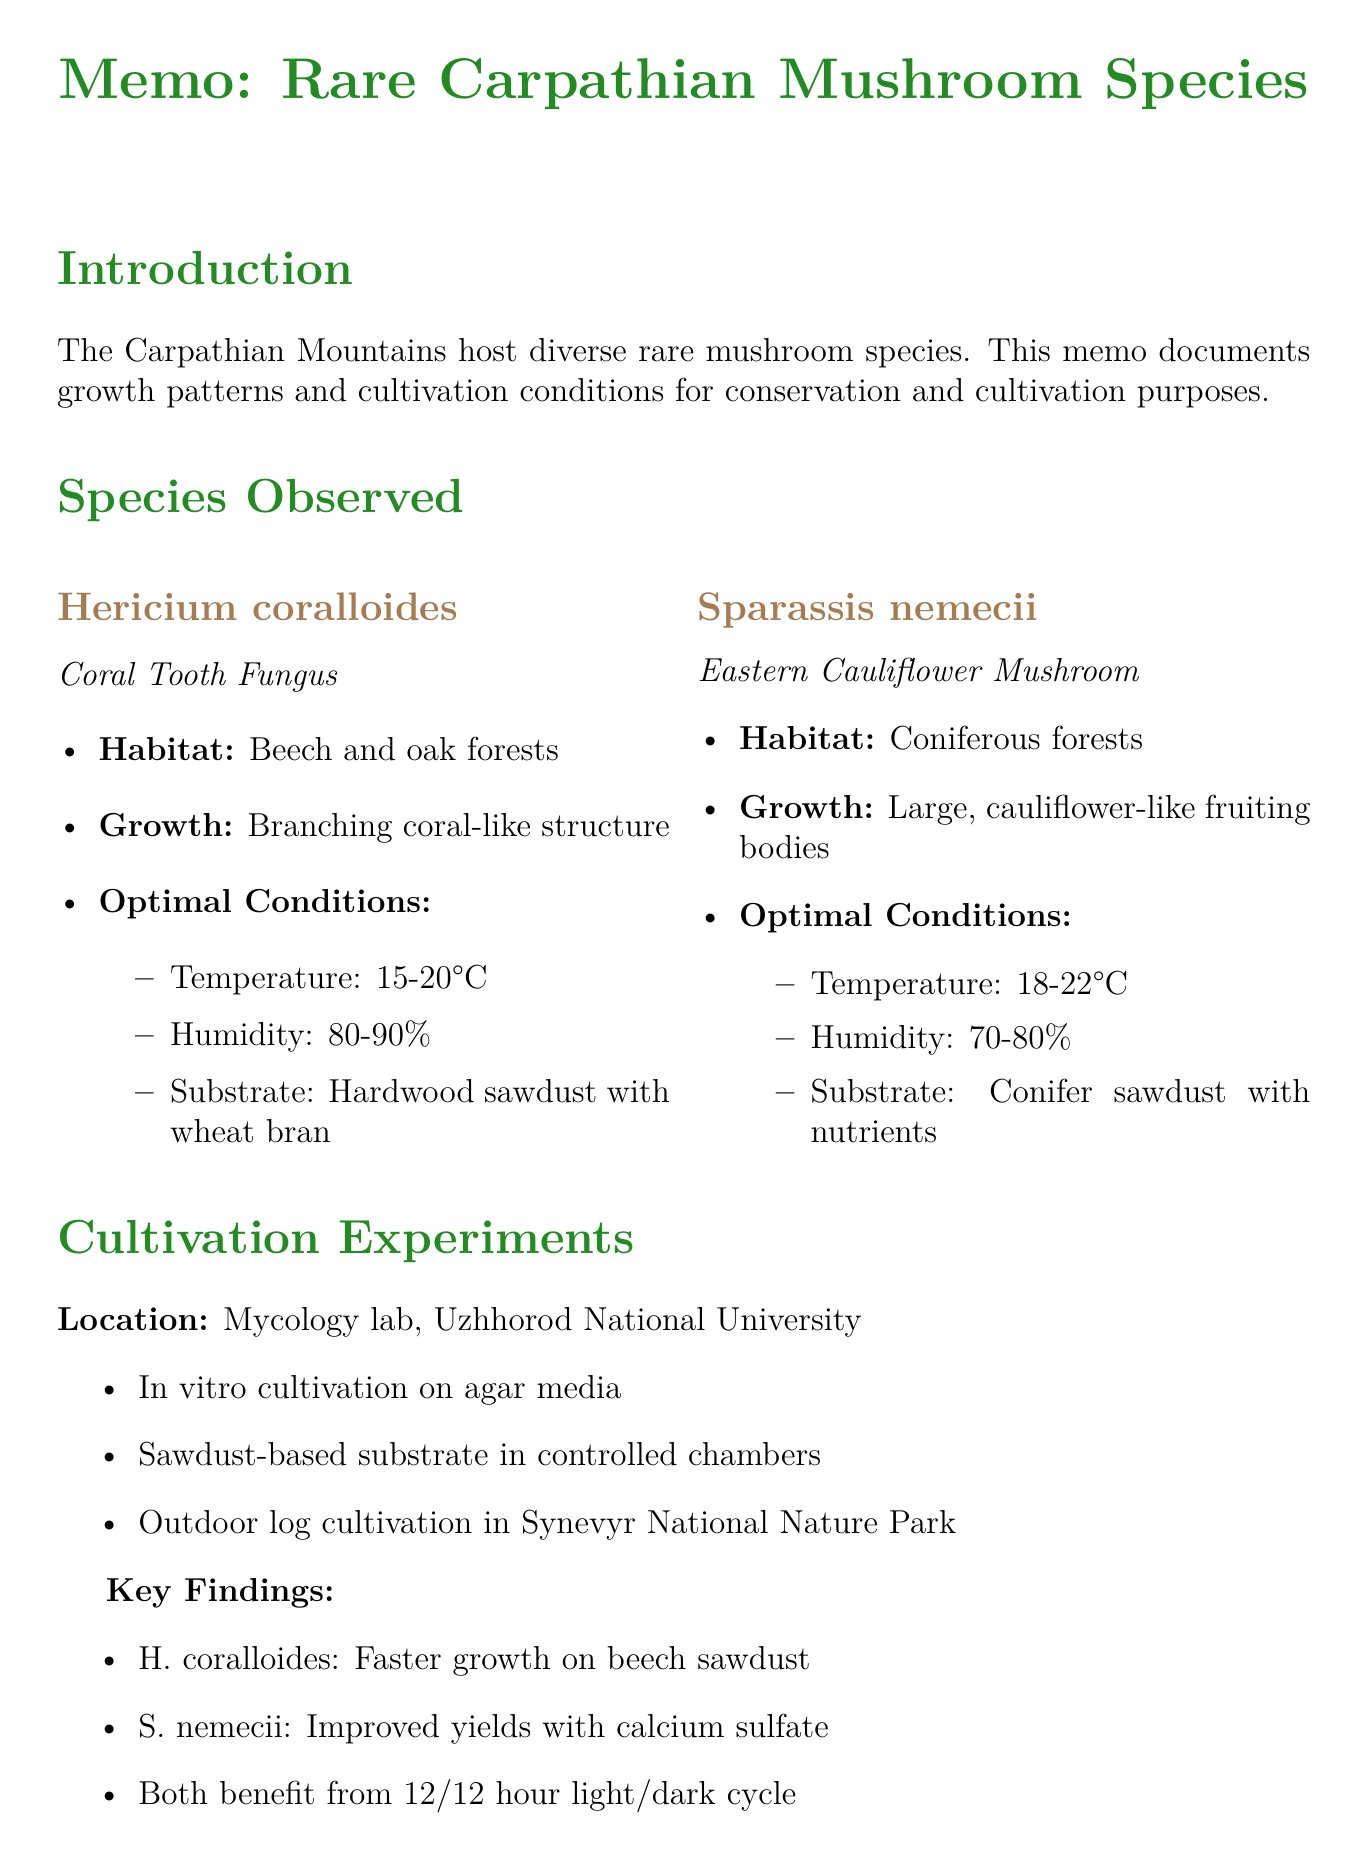What is the habitat of Hericium coralloides? The habitat of Hericium coralloides is mentioned as beech and oak forests in the Ukrainian Carpathians.
Answer: Beech and oak forests What temperature range is optimal for Sparassis nemecii? The document states that the optimal temperature for Sparassis nemecii is between 18-22°C.
Answer: 18-22°C Which mushroom species showed faster growth on beech sawdust? According to the findings, Hericium coralloides showed faster growth rates on beech sawdust compared to oak.
Answer: Hericium coralloides What is one key finding regarding S. nemecii? The document mentions that Sparassis nemecii exhibited improved yields when calcium sulfate was added to the substrate.
Answer: Improved yields with calcium sulfate Which institution conducted the cultivation experiments? The cultivation experiments were conducted at the Mycology laboratory at Uzhhorod National University.
Answer: Uzhhorod National University What are the future research directions mentioned in the document? The document lists several future research directions, including genetic diversity studies, investigation of mycorrhizal relationships, and exploration of bioactive compounds.
Answer: Genetic diversity studies What is one implication of the conservation efforts mentioned? The document mentions that identification of specific microhabitats is crucial for natural growth, which is listed as a conservation implication.
Answer: Identification of specific microhabitats Which society is noted for local collaborations? The Ukrainian Botanical Society is mentioned as a partner for field surveys in local collaborations.
Answer: Ukrainian Botanical Society 